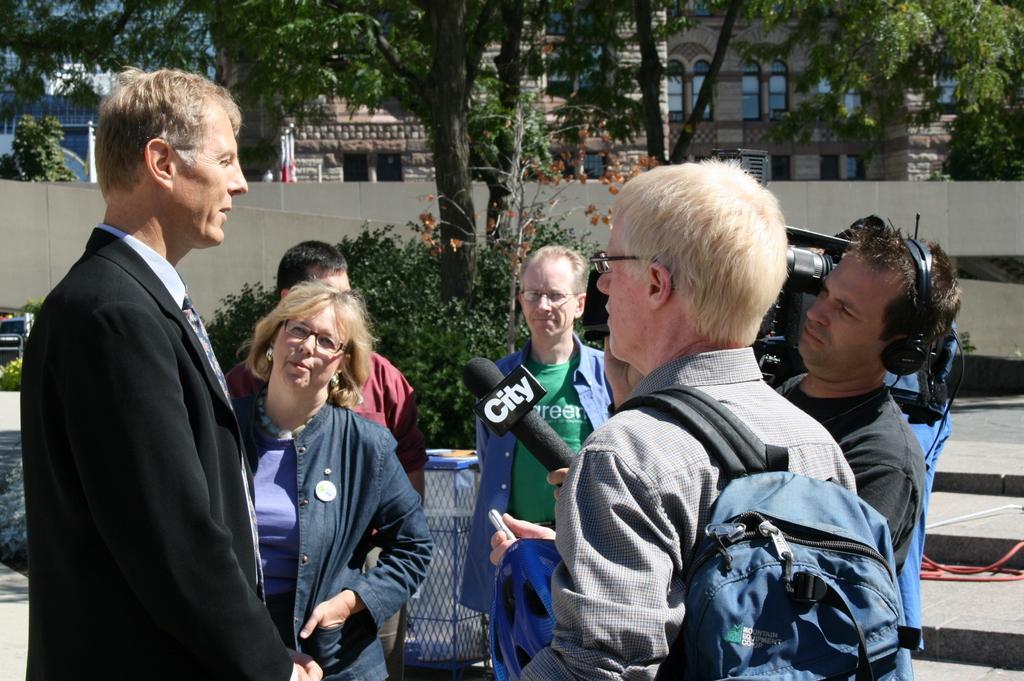Could you give a brief overview of what you see in this image? In this picture I can see few people are standing and a man holding a microphone in his hand and holding a camera with another hand and I can see trees and buildings in the back and I can see a wall and a man is wearing a bag. 